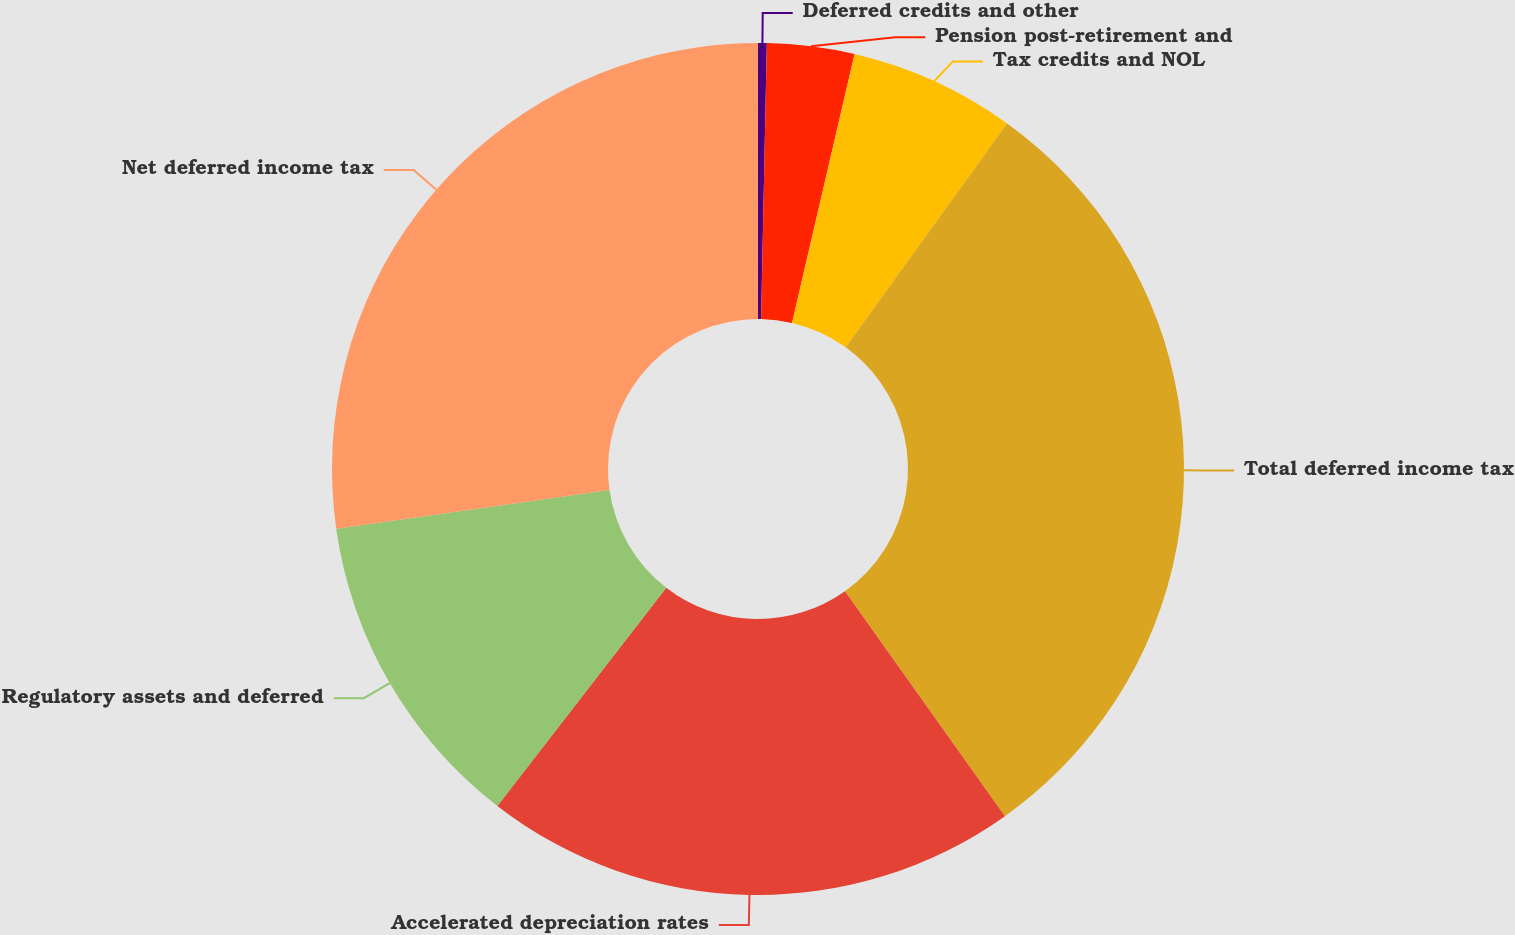Convert chart. <chart><loc_0><loc_0><loc_500><loc_500><pie_chart><fcel>Deferred credits and other<fcel>Pension post-retirement and<fcel>Tax credits and NOL<fcel>Total deferred income tax<fcel>Accelerated depreciation rates<fcel>Regulatory assets and deferred<fcel>Net deferred income tax<nl><fcel>0.33%<fcel>3.31%<fcel>6.3%<fcel>30.22%<fcel>20.32%<fcel>12.28%<fcel>27.24%<nl></chart> 